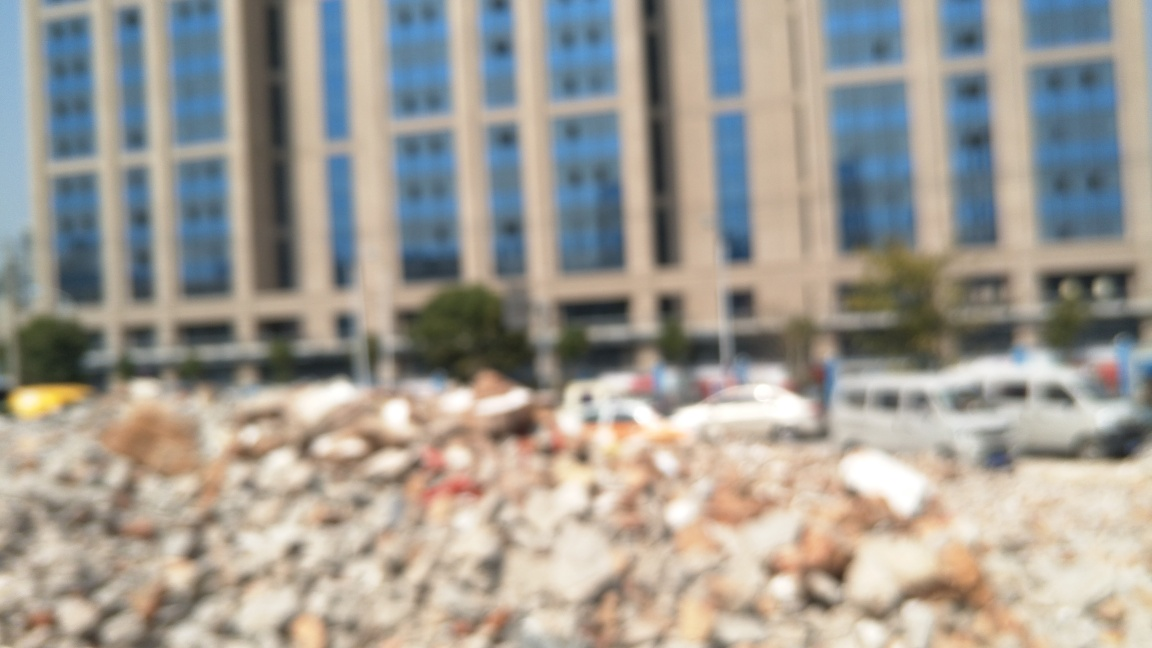What could be the reason behind the blurring effect seen in this image? The blurring effect might be due to a variety of reasons. It could be an artistic choice, attempting to convey a specific feeling or mood such as confusion, chaos, or the passage of time. Alternatively, it might be a result of a technical issue, like a camera shake or incorrect focus settings during the capture of the photo. However, if it's an intentional artistic effect, it serves to draw the viewer's attention more to the overall impression of the scene rather than the specific details. 